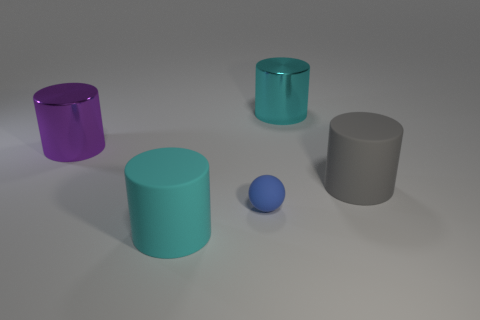Do the tiny thing and the purple cylinder have the same material?
Keep it short and to the point. No. How many things are either gray objects or large cylinders in front of the purple object?
Provide a succinct answer. 2. Is the number of large metallic cylinders that are behind the gray rubber object greater than the number of large things that are to the right of the big cyan metal thing?
Make the answer very short. Yes. Are there any other things that are the same color as the rubber sphere?
Provide a short and direct response. No. What number of objects are yellow cubes or matte things?
Provide a succinct answer. 3. Does the cyan thing behind the gray cylinder have the same size as the small ball?
Offer a terse response. No. What number of other objects are there of the same size as the purple shiny thing?
Your answer should be very brief. 3. Is there a tiny matte object?
Make the answer very short. Yes. There is a cyan cylinder in front of the shiny object that is to the left of the blue thing; what size is it?
Your answer should be very brief. Large. Do the matte cylinder that is to the left of the cyan shiny object and the big metallic cylinder that is on the right side of the matte ball have the same color?
Your answer should be very brief. Yes. 